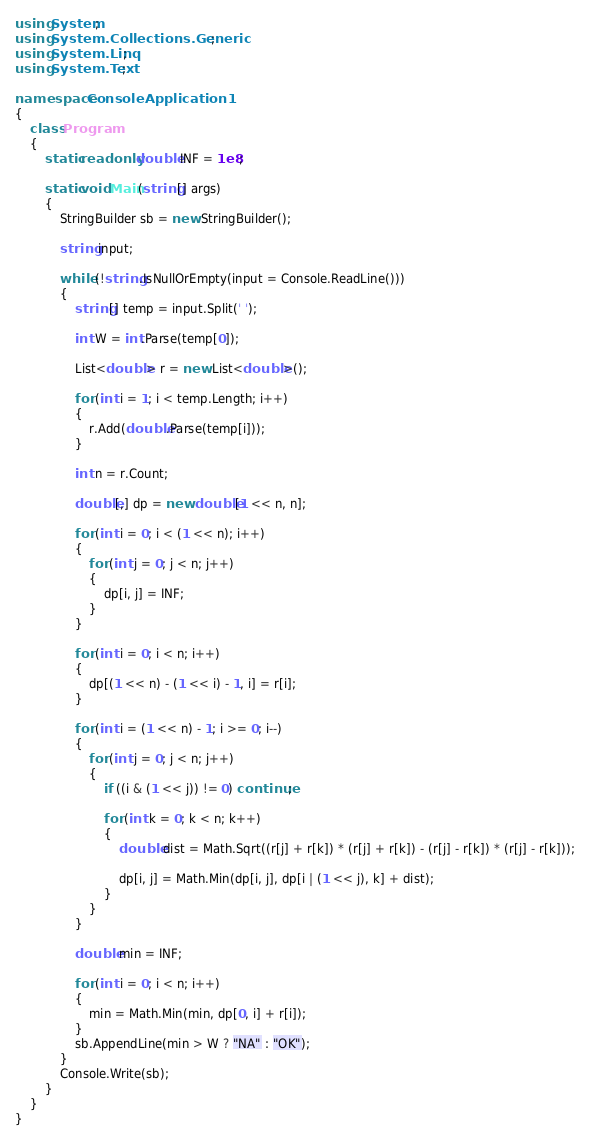<code> <loc_0><loc_0><loc_500><loc_500><_C#_>using System;
using System.Collections.Generic;
using System.Linq;
using System.Text;

namespace ConsoleApplication1
{
    class Program
    {
        static readonly double INF = 1e8;

        static void Main(string[] args)
        {
            StringBuilder sb = new StringBuilder();

            string input;

            while (!string.IsNullOrEmpty(input = Console.ReadLine()))
            {
                string[] temp = input.Split(' ');

                int W = int.Parse(temp[0]);

                List<double> r = new List<double>();

                for (int i = 1; i < temp.Length; i++)
                {
                    r.Add(double.Parse(temp[i]));
                }

                int n = r.Count;

                double[,] dp = new double[1 << n, n];

                for (int i = 0; i < (1 << n); i++)
                {
                    for (int j = 0; j < n; j++)
                    {
                        dp[i, j] = INF;
                    }
                }

                for (int i = 0; i < n; i++)
                {
                    dp[(1 << n) - (1 << i) - 1, i] = r[i];
                }

                for (int i = (1 << n) - 1; i >= 0; i--)
                {
                    for (int j = 0; j < n; j++)
                    {
                        if ((i & (1 << j)) != 0) continue;

                        for (int k = 0; k < n; k++)
                        {
                            double dist = Math.Sqrt((r[j] + r[k]) * (r[j] + r[k]) - (r[j] - r[k]) * (r[j] - r[k]));

                            dp[i, j] = Math.Min(dp[i, j], dp[i | (1 << j), k] + dist);
                        }
                    }
                }

                double min = INF;

                for (int i = 0; i < n; i++)
                {
                    min = Math.Min(min, dp[0, i] + r[i]);
                }
                sb.AppendLine(min > W ? "NA" : "OK");
            }
            Console.Write(sb);
        }
    }
}</code> 